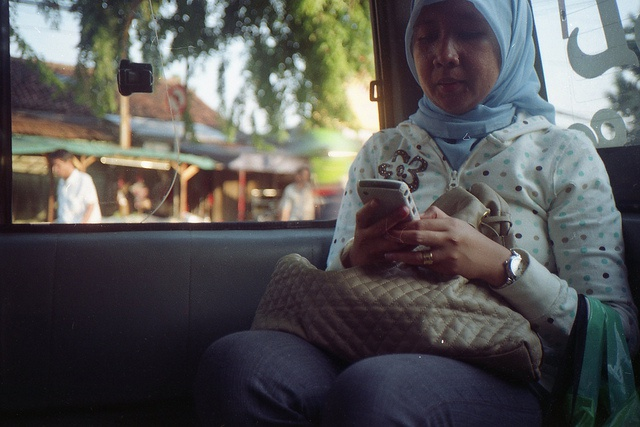Describe the objects in this image and their specific colors. I can see car in black, gray, lightgray, and darkgray tones, people in black, gray, and darkgray tones, handbag in black and gray tones, people in black, lightgray, tan, darkgray, and gray tones, and cell phone in black, darkgray, and gray tones in this image. 